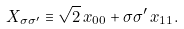Convert formula to latex. <formula><loc_0><loc_0><loc_500><loc_500>X _ { \sigma \sigma ^ { \prime } } \equiv \sqrt { 2 } \, x _ { 0 0 } + \sigma \sigma ^ { \prime } \, x _ { 1 1 } .</formula> 